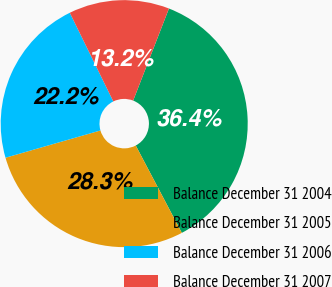<chart> <loc_0><loc_0><loc_500><loc_500><pie_chart><fcel>Balance December 31 2004<fcel>Balance December 31 2005<fcel>Balance December 31 2006<fcel>Balance December 31 2007<nl><fcel>36.38%<fcel>28.27%<fcel>22.19%<fcel>13.16%<nl></chart> 